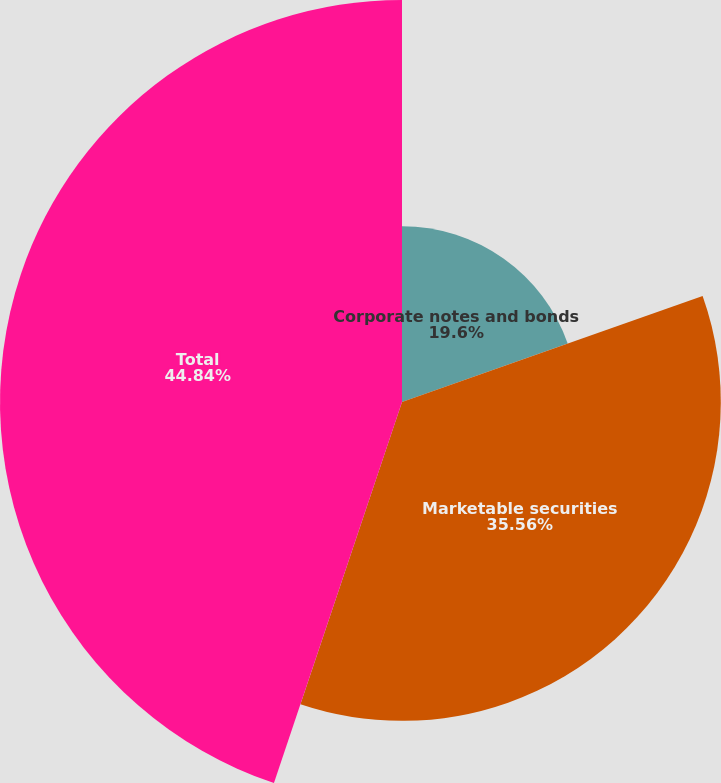Convert chart. <chart><loc_0><loc_0><loc_500><loc_500><pie_chart><fcel>Corporate notes and bonds<fcel>Marketable securities<fcel>Total<nl><fcel>19.6%<fcel>35.56%<fcel>44.84%<nl></chart> 